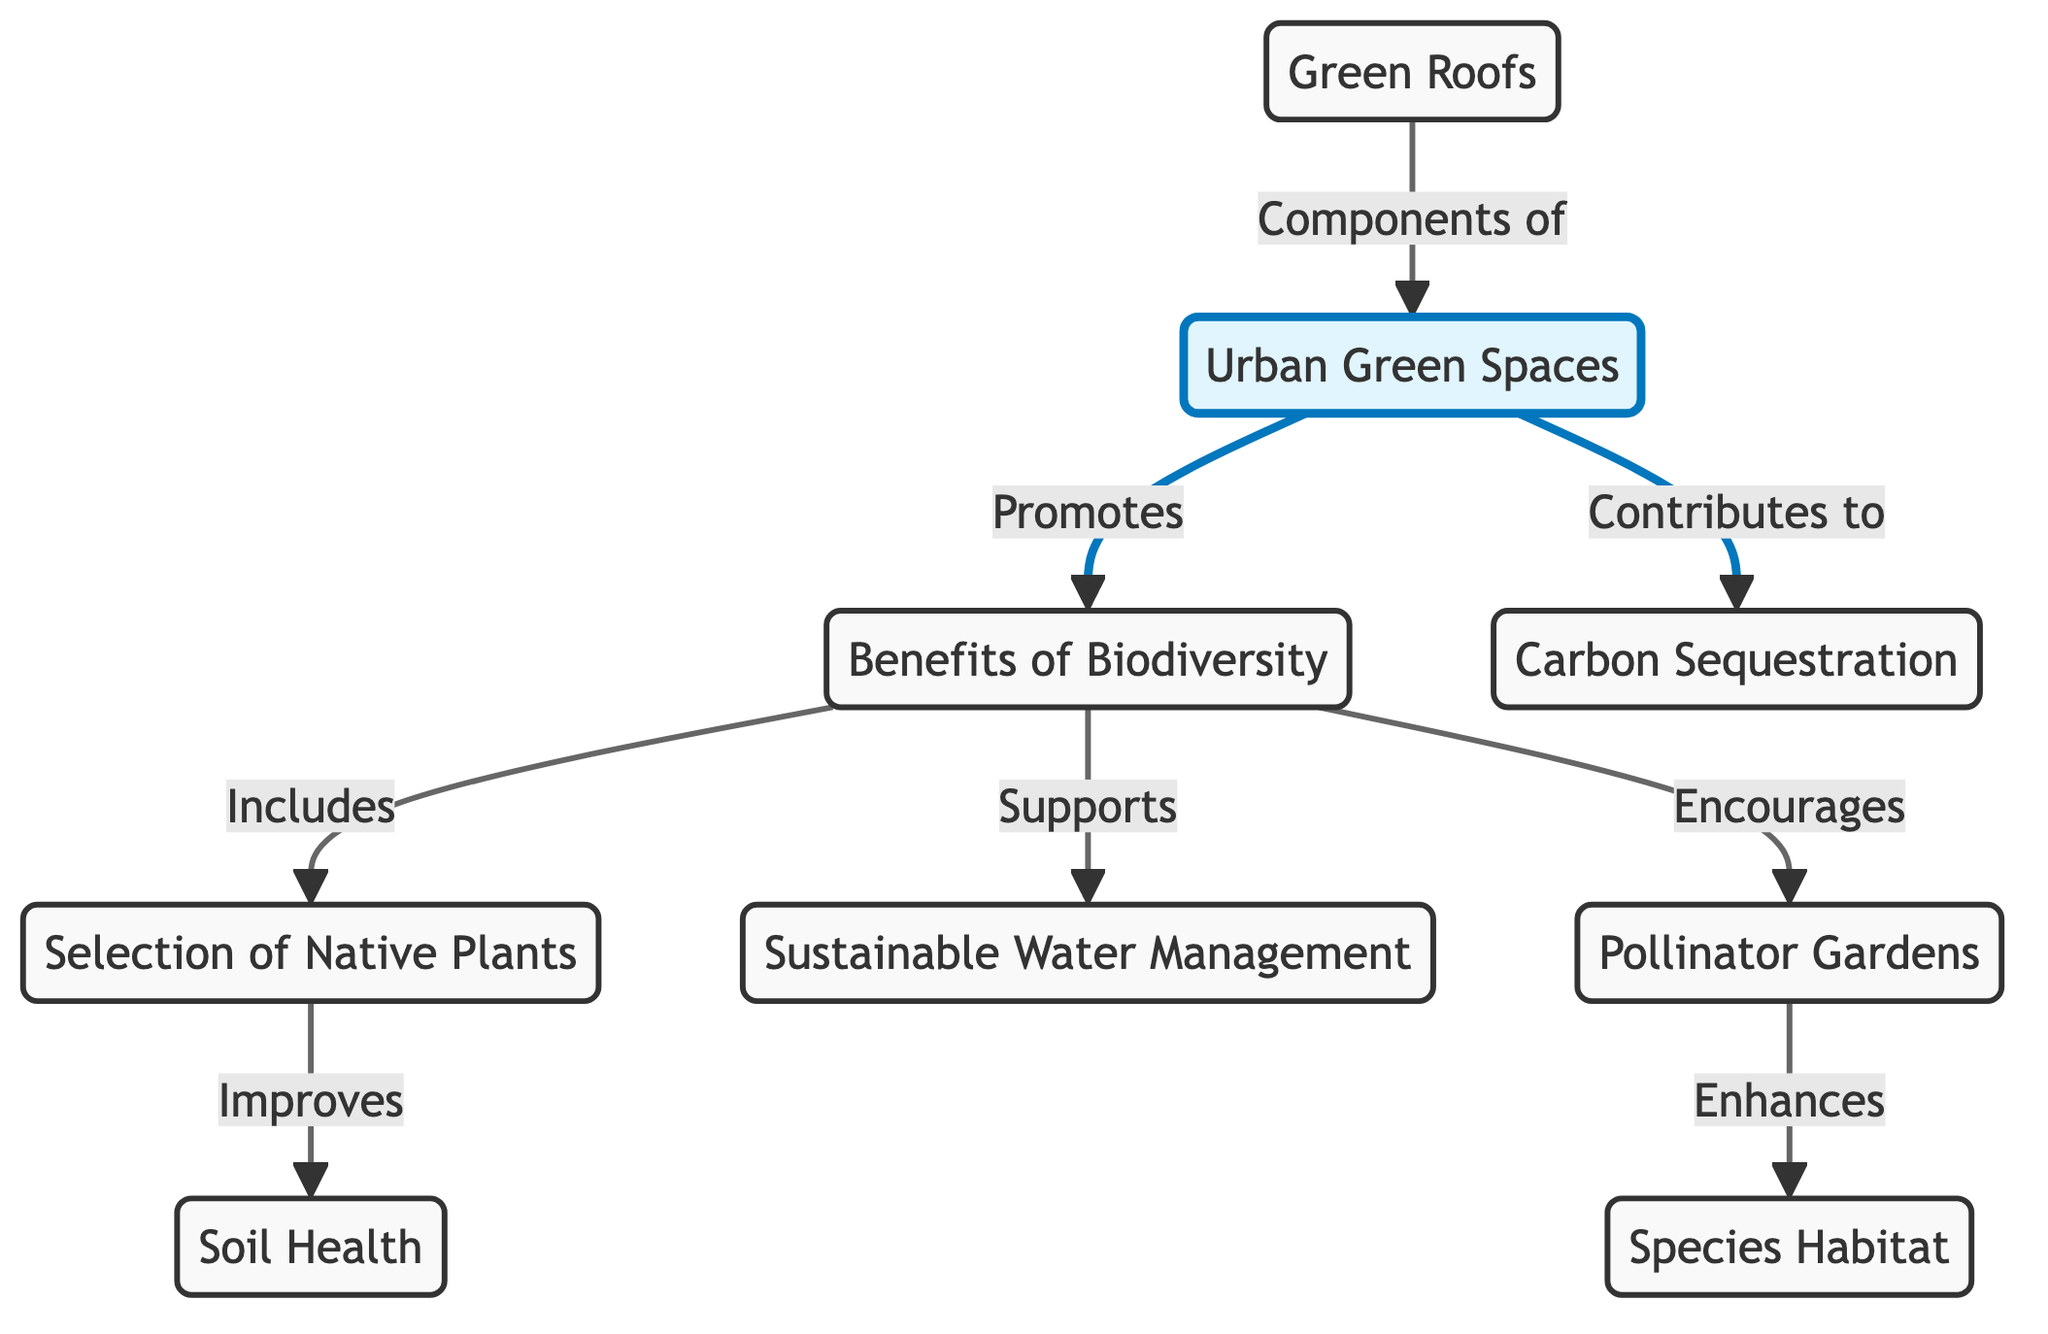What are the benefits of biodiversity in urban green spaces? The diagram labels one of the main nodes as "Benefits of Biodiversity," indicating that it is the central focus of the related elements stemming from it. The direct connections from this node represent specific benefits of biodiversity, including the selection of native plants, sustainable water management, and pollinator gardens.
Answer: Benefits of Biodiversity How many components related to urban green spaces are shown in the diagram? The diagram includes six nodes that connect specifically to urban green spaces, which include benefits like native plants, sustainable water management, pollinator gardens, green roofs, and contributions to carbon sequestration. Counting these gives us a total of six components.
Answer: Six Which node is directly related to sustainable water management? In the diagram, sustainable water management is a direct beneficiary of biodiversity and is connected to the "Benefits of Biodiversity" node. This relationship can be traced as beneficial support, leading from the biodiversity overview to sustainable practices.
Answer: Sustainable Water Management Which aspect enhances species habitat? The connection from pollinator gardens to species habitat in the diagram indicates that pollinator gardens specifically enhance the habitat for various species. This means that the promotion of these gardens is directly linked to improving the living conditions or habitats for species within urban green spaces.
Answer: Pollinator Gardens What contributes to carbon sequestration in urban green spaces? The diagram indicates that urban green spaces contribute to carbon sequestration, implying a beneficial role in absorbing carbon from the atmosphere through elements in these spaces like plants and trees, which are designed to enhance ecological function.
Answer: Urban Green Spaces How does the selection of native plants improve soil health? The diagram shows a direct link from "Selection of Native Plants" to "Soil Health," indicating that employing native plants in urban landscapes leads to improved soil conditions. This is likely due to the compatibility of native species with local soil, which can enhance its nutrients and structure.
Answer: Improves Soil Health What role do green roofs play in urban green spaces? Green roofs are identified in the diagram as components of urban green spaces, suggesting that they are structural features that contribute to the overall eco-friendliness and biodiversity of urban environments, enhancing aesthetic and ecological functions.
Answer: Components of Urban Green Spaces 